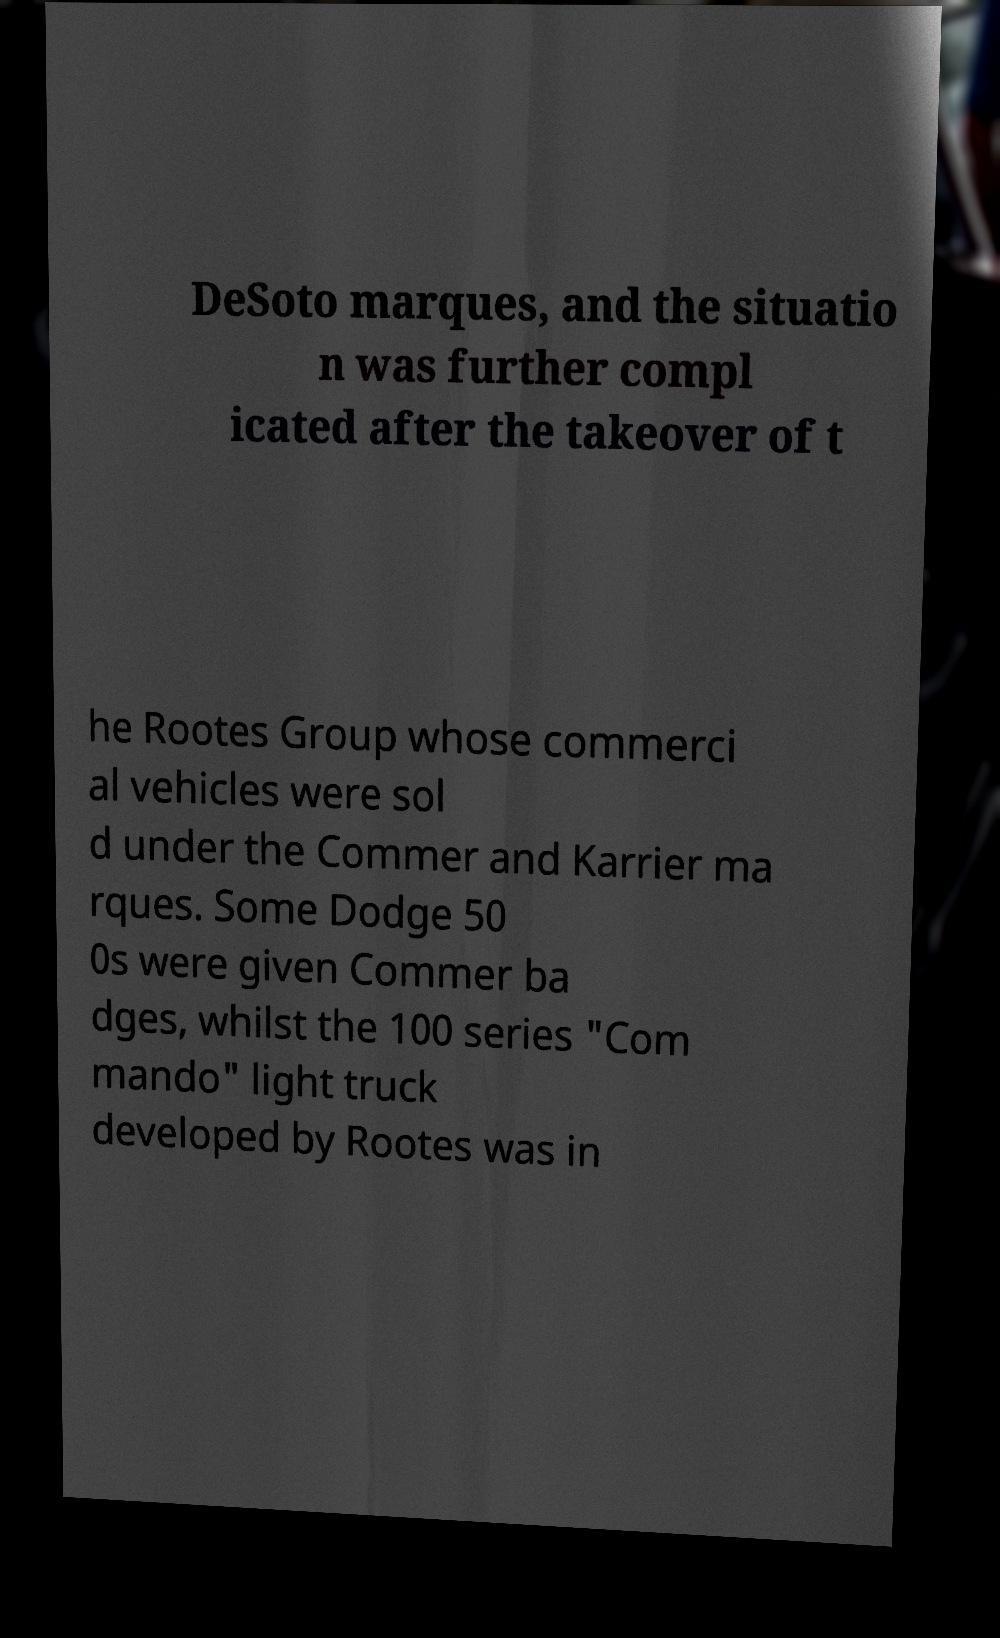Can you read and provide the text displayed in the image?This photo seems to have some interesting text. Can you extract and type it out for me? DeSoto marques, and the situatio n was further compl icated after the takeover of t he Rootes Group whose commerci al vehicles were sol d under the Commer and Karrier ma rques. Some Dodge 50 0s were given Commer ba dges, whilst the 100 series "Com mando" light truck developed by Rootes was in 